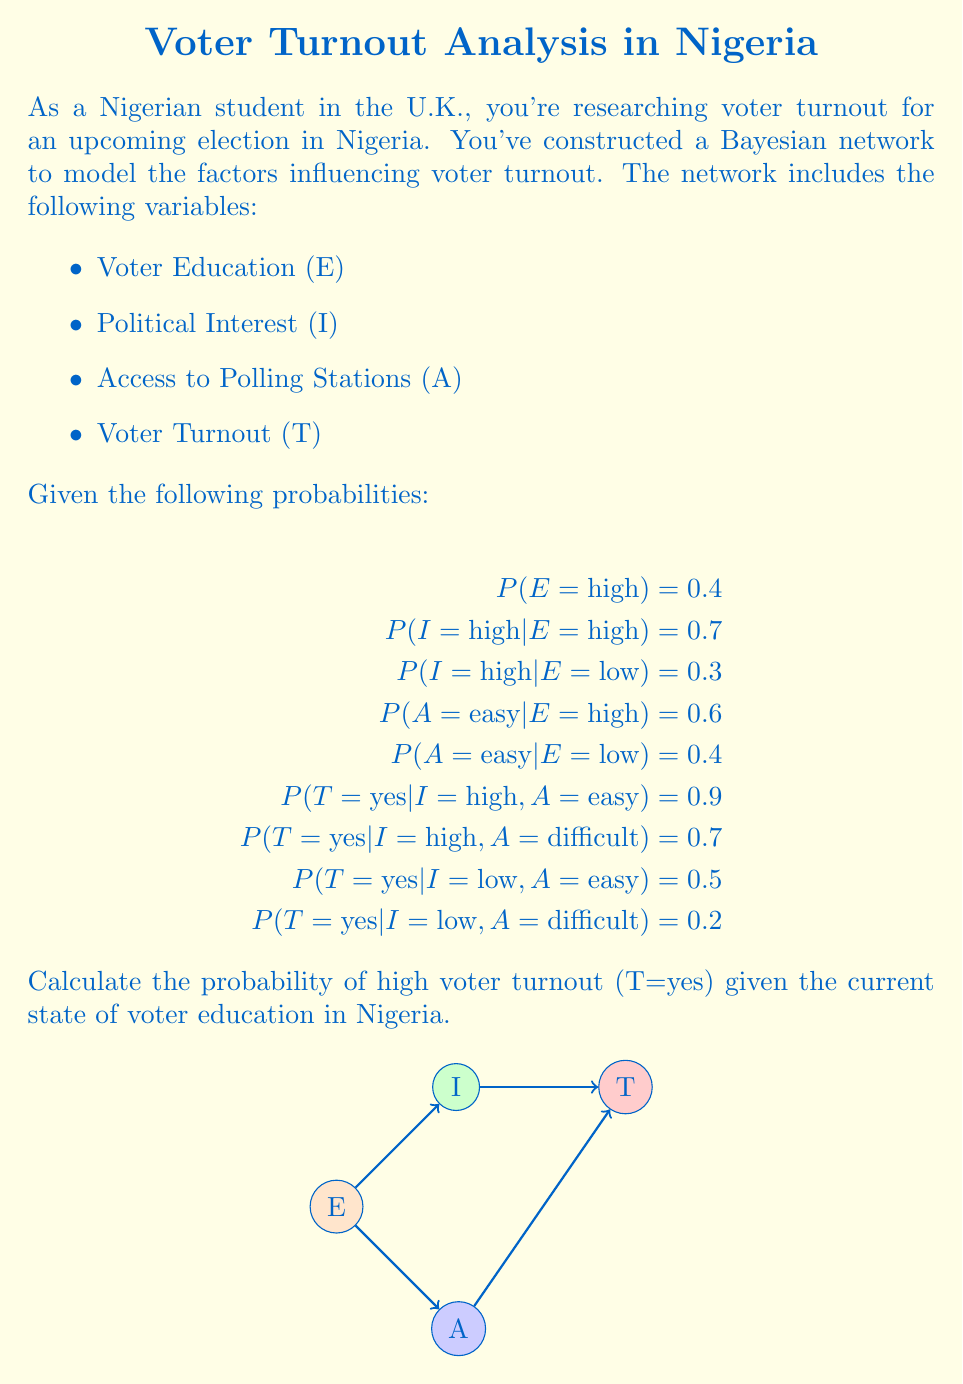Give your solution to this math problem. To solve this problem, we'll use the law of total probability and Bayes' theorem. Let's break it down step-by-step:

1) First, we need to calculate P(I=high) and P(A=easy) using the law of total probability:

   $$P(I=\text{high}) = P(I=\text{high}|E=\text{high})P(E=\text{high}) + P(I=\text{high}|E=\text{low})P(E=\text{low})$$
   $$= 0.7 \times 0.4 + 0.3 \times 0.6 = 0.28 + 0.18 = 0.46$$

   $$P(A=\text{easy}) = P(A=\text{easy}|E=\text{high})P(E=\text{high}) + P(A=\text{easy}|E=\text{low})P(E=\text{low})$$
   $$= 0.6 \times 0.4 + 0.4 \times 0.6 = 0.24 + 0.24 = 0.48$$

2) Now, we can calculate P(T=yes) using the law of total probability again:

   $$P(T=\text{yes}) = P(T=\text{yes}|I=\text{high}, A=\text{easy})P(I=\text{high})P(A=\text{easy}) +$$
   $$P(T=\text{yes}|I=\text{high}, A=\text{difficult})P(I=\text{high})P(A=\text{difficult}) +$$
   $$P(T=\text{yes}|I=\text{low}, A=\text{easy})P(I=\text{low})P(A=\text{easy}) +$$
   $$P(T=\text{yes}|I=\text{low}, A=\text{difficult})P(I=\text{low})P(A=\text{difficult})$$

3) Substituting the values:

   $$P(T=\text{yes}) = 0.9 \times 0.46 \times 0.48 + 0.7 \times 0.46 \times 0.52 +$$
   $$0.5 \times 0.54 \times 0.48 + 0.2 \times 0.54 \times 0.52$$

4) Calculating:

   $$P(T=\text{yes}) = 0.19872 + 0.16744 + 0.12960 + 0.05616 = 0.55192$$

Therefore, the probability of high voter turnout (T=yes) given the current state of voter education in Nigeria is approximately 0.55192 or 55.192%.
Answer: 0.55192 (or 55.192%) 